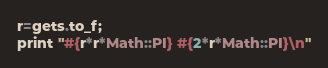<code> <loc_0><loc_0><loc_500><loc_500><_Ruby_>r=gets.to_f;
print "#{r*r*Math::PI} #{2*r*Math::PI}\n"
</code> 